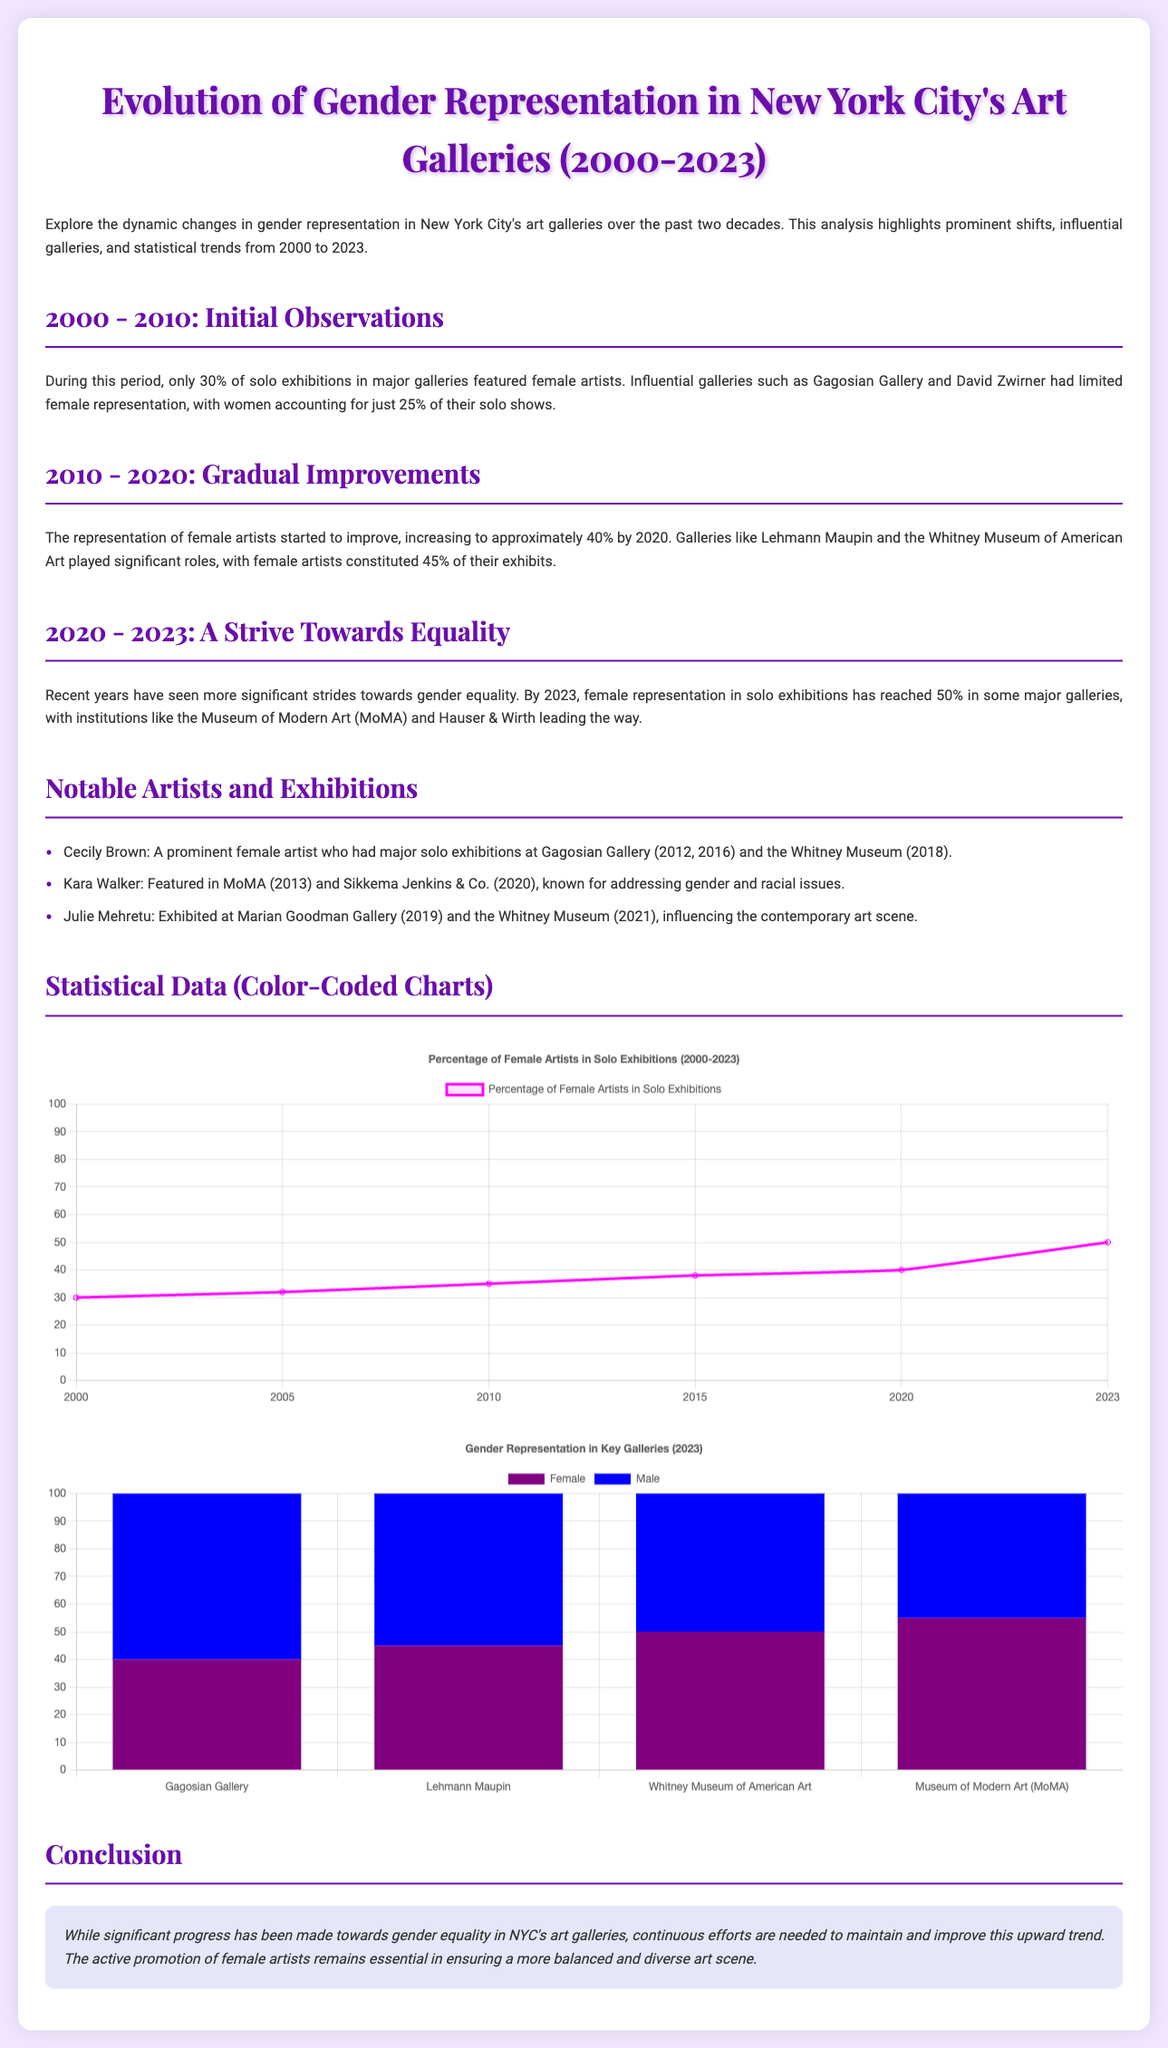what was the percentage of female artists in solo exhibitions in 2000? The document states that only 30% of solo exhibitions featured female artists in 2000.
Answer: 30% which galleries had limited female representation in the 2000-2010 period? The document mentions Gagosian Gallery and David Zwirner had limited female representation.
Answer: Gagosian Gallery, David Zwirner what was the percentage of female artists represented by Lehmann Maupin in 2020? The document indicates that female artists constituted 45% of their exhibits by 2020.
Answer: 45% what is the percentage of female representation in the Museum of Modern Art by 2023? The document notes that female representation in MoMA has reached 50% by 2023.
Answer: 50% who is a notable artist with major solo exhibitions at the Whitney Museum? The document lists Cecily Brown as a prominent female artist with exhibitions at the Whitney Museum.
Answer: Cecily Brown what significant shift in female representation occurred by 2023? The document states that by 2023, female representation in solo exhibitions reached 50%.
Answer: 50% which color represents male artists in the bar chart? The document specifies that the background color for male artists in the bar chart is blue.
Answer: Blue what does the line chart indicate about female representation from 2010 to 2023? The line chart shows that the percentage of female artists in solo exhibitions increased from 35% to 50% during this period.
Answer: Increased which decade shows a gradual improvement in female representation? The document highlights the decade from 2010 to 2020 as showing gradual improvements in female representation.
Answer: 2010-2020 